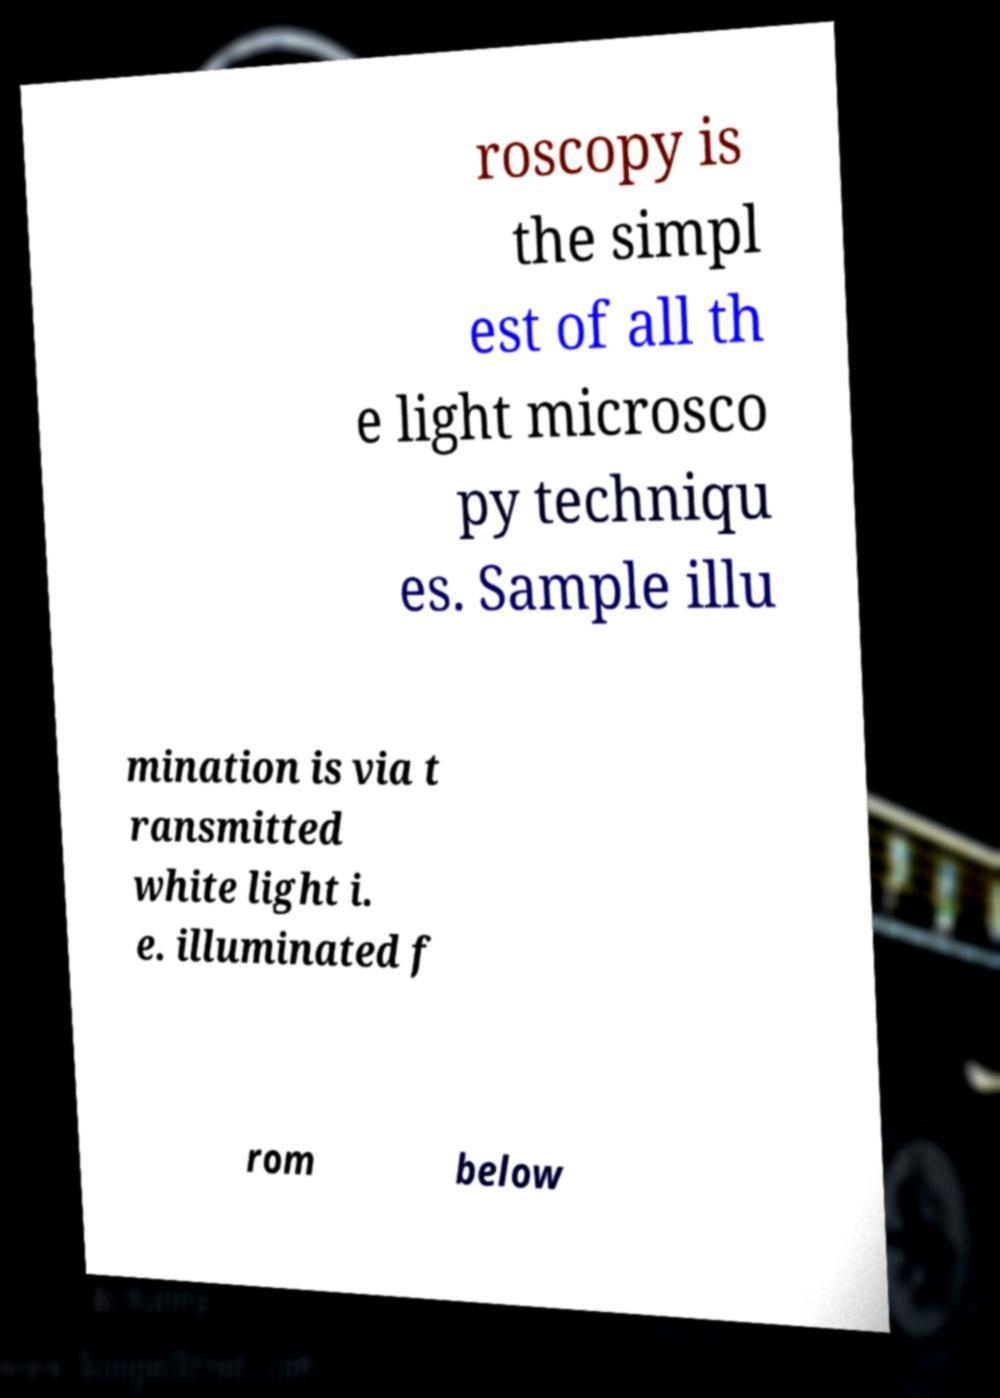Please read and relay the text visible in this image. What does it say? roscopy is the simpl est of all th e light microsco py techniqu es. Sample illu mination is via t ransmitted white light i. e. illuminated f rom below 